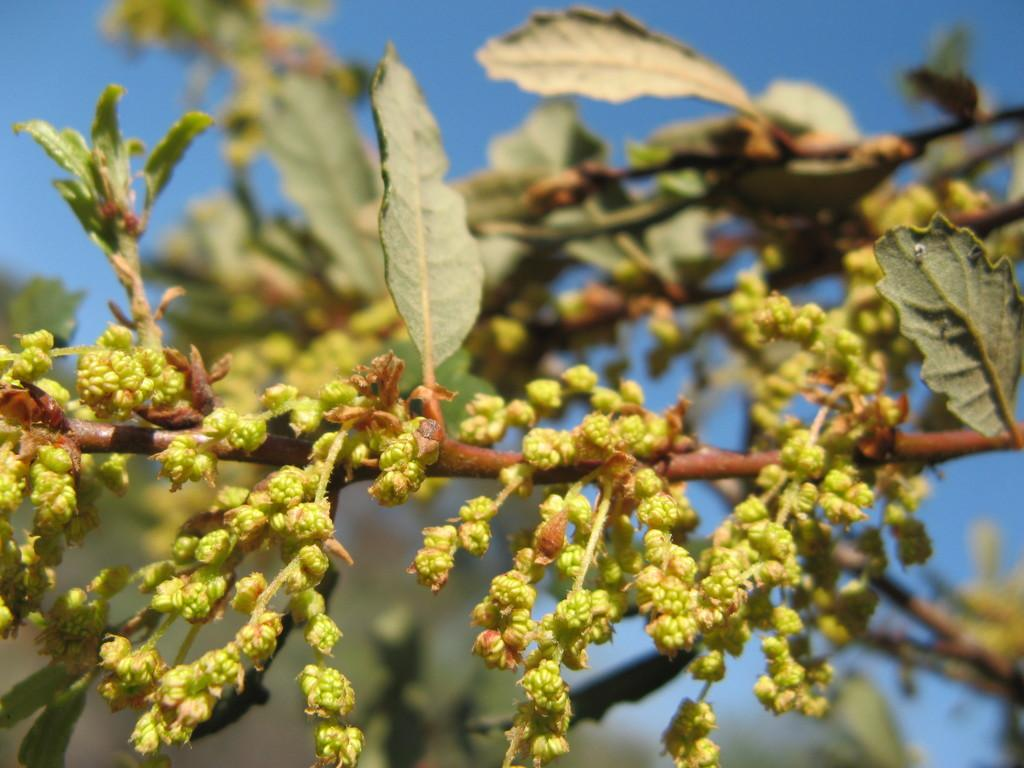What type of plant life is present in the image? There are buds and leaves in the image. Can you describe the background of the image? The sky is visible in the background of the image. How many frogs can be seen jumping in the image? There are no frogs present in the image. Is there any snow visible in the image? There is no snow present in the image. 